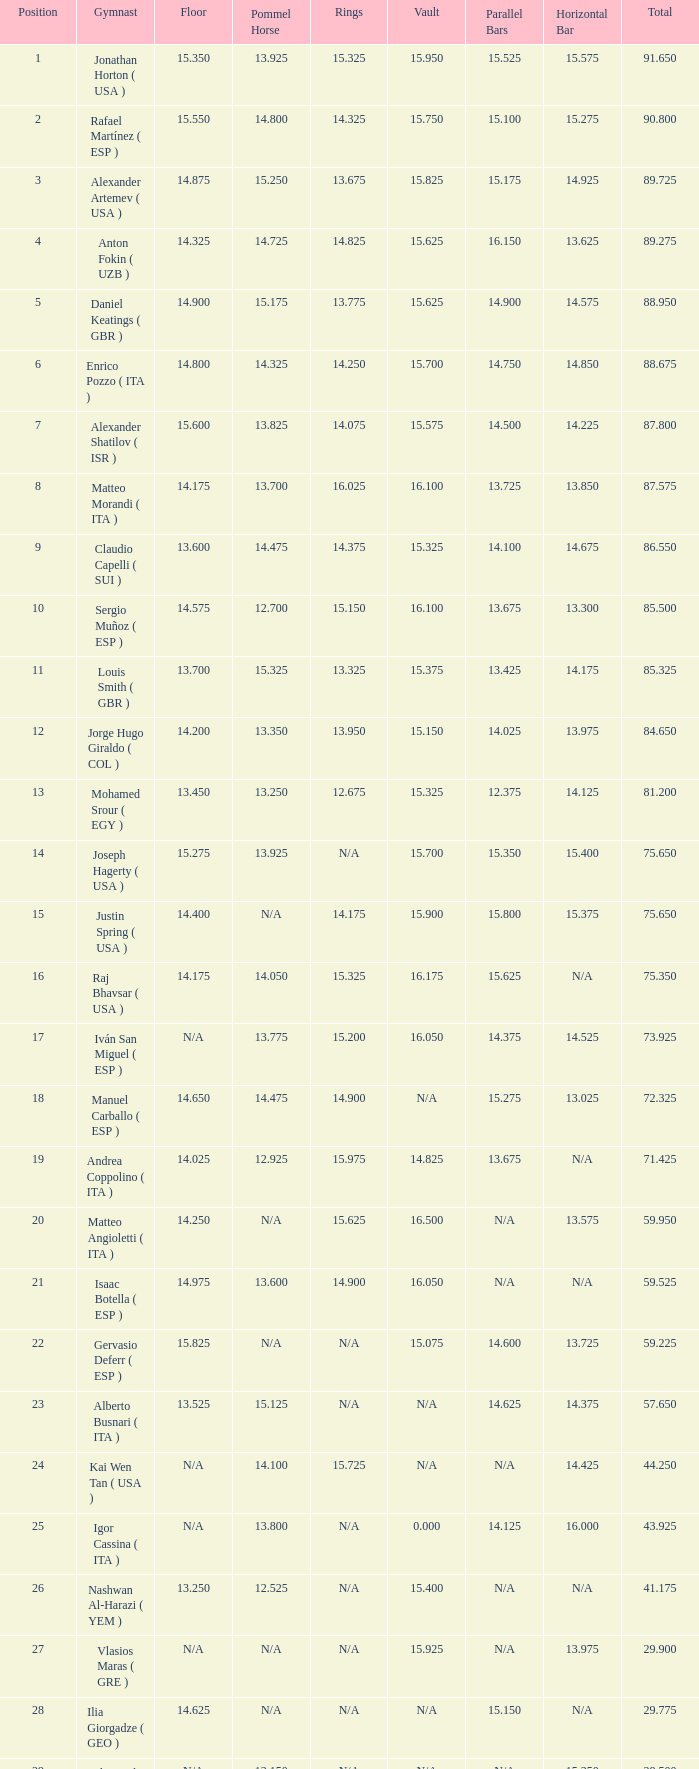200, what is the number for the parallel bars? 14.025. 